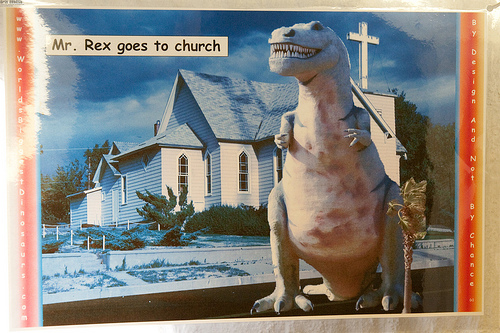<image>
Is there a toy on the ground? No. The toy is not positioned on the ground. They may be near each other, but the toy is not supported by or resting on top of the ground. Is the dinosaur behind the church? No. The dinosaur is not behind the church. From this viewpoint, the dinosaur appears to be positioned elsewhere in the scene. 